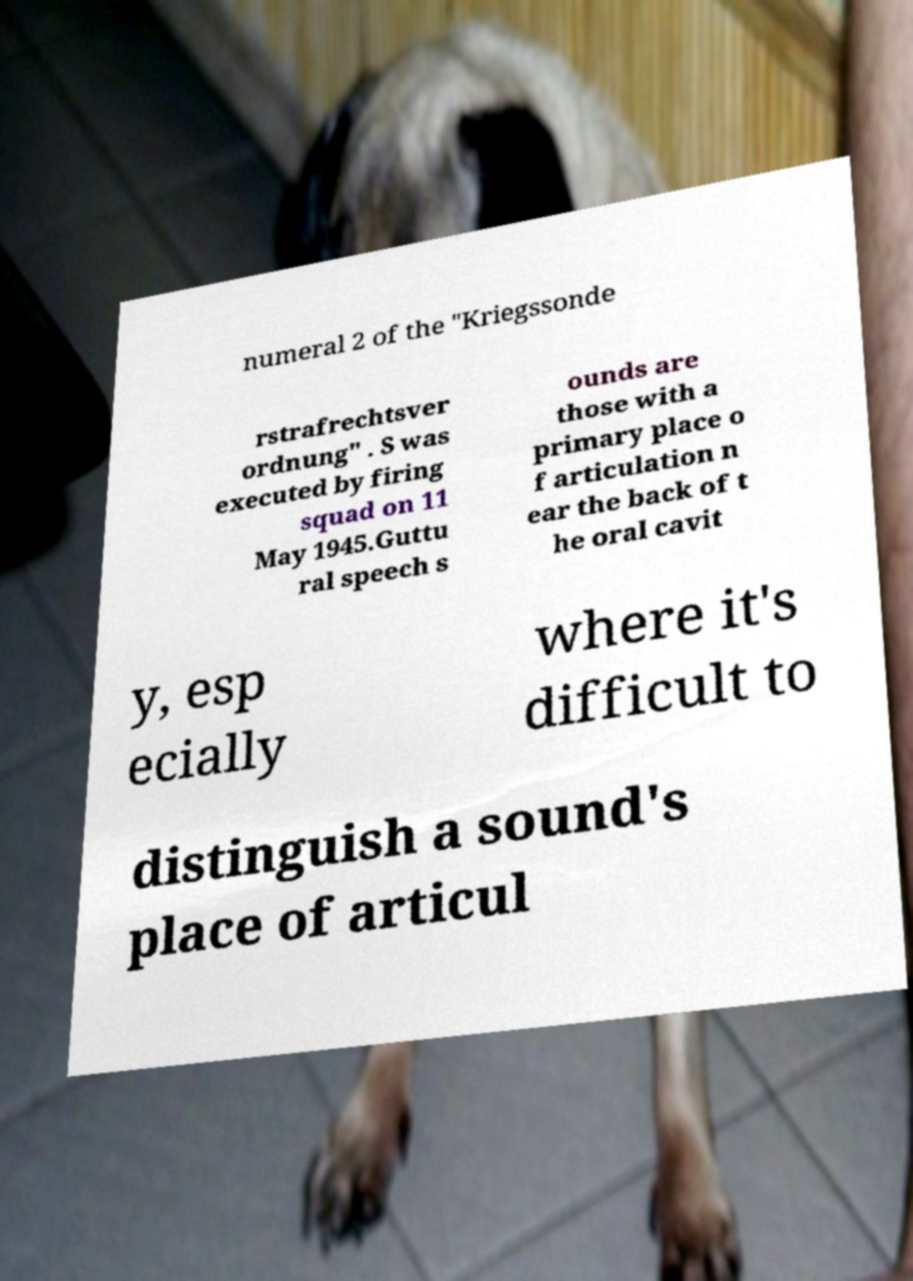There's text embedded in this image that I need extracted. Can you transcribe it verbatim? numeral 2 of the "Kriegssonde rstrafrechtsver ordnung" . S was executed by firing squad on 11 May 1945.Guttu ral speech s ounds are those with a primary place o f articulation n ear the back of t he oral cavit y, esp ecially where it's difficult to distinguish a sound's place of articul 